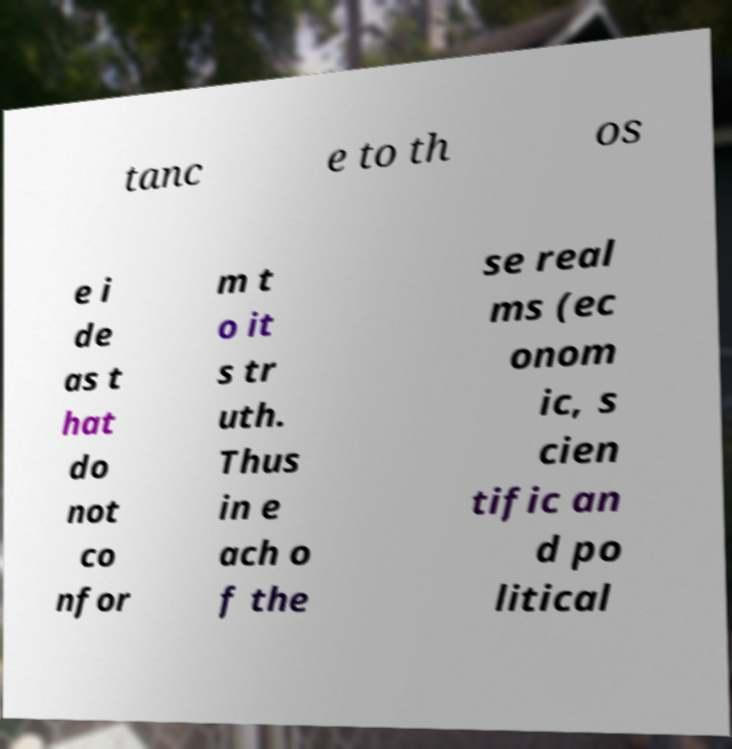For documentation purposes, I need the text within this image transcribed. Could you provide that? tanc e to th os e i de as t hat do not co nfor m t o it s tr uth. Thus in e ach o f the se real ms (ec onom ic, s cien tific an d po litical 